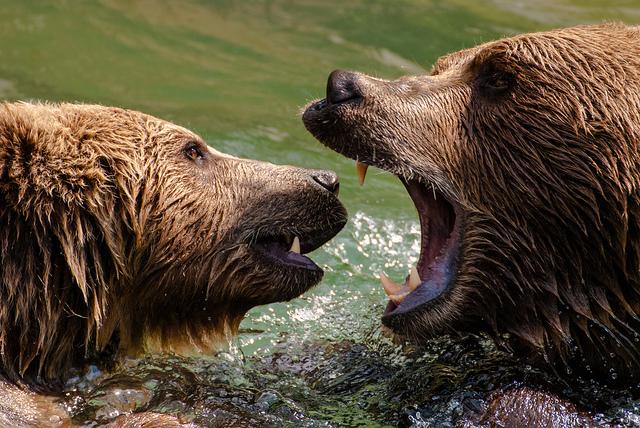Which animals are this?
Answer briefly. Bears. What emotion is the bear showing?
Answer briefly. Anger. Are these bears brown?
Answer briefly. Yes. 